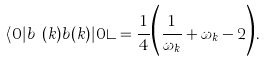Convert formula to latex. <formula><loc_0><loc_0><loc_500><loc_500>\langle 0 | b ^ { \dagger } ( k ) b ( k ) | 0 \rangle = \frac { 1 } { 4 } \Big { ( } \frac { 1 } { \omega _ { k } } + \omega _ { k } - 2 \Big { ) } .</formula> 